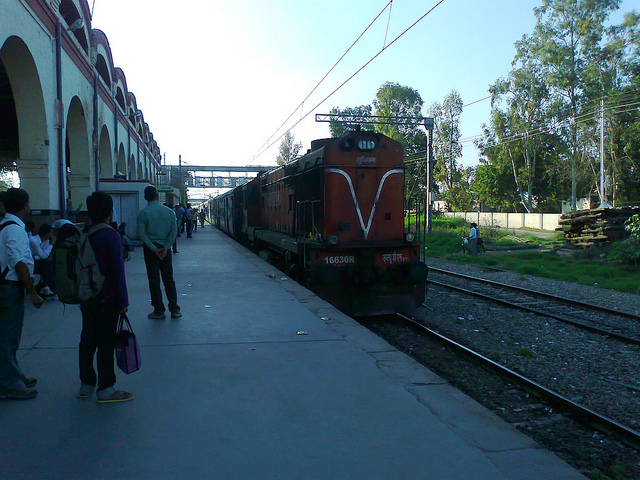Please transcribe the text information in this image. 1663OR 